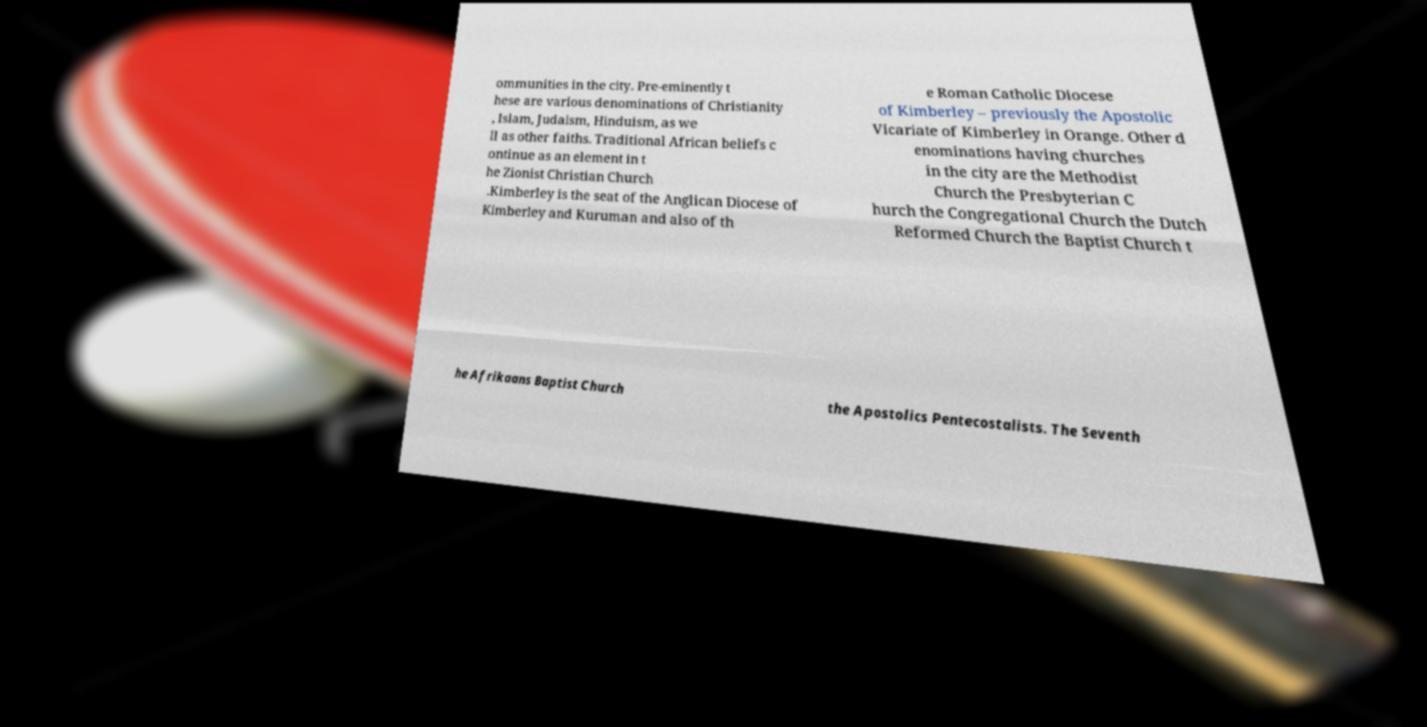Can you read and provide the text displayed in the image?This photo seems to have some interesting text. Can you extract and type it out for me? ommunities in the city. Pre-eminently t hese are various denominations of Christianity , Islam, Judaism, Hinduism, as we ll as other faiths. Traditional African beliefs c ontinue as an element in t he Zionist Christian Church .Kimberley is the seat of the Anglican Diocese of Kimberley and Kuruman and also of th e Roman Catholic Diocese of Kimberley – previously the Apostolic Vicariate of Kimberley in Orange. Other d enominations having churches in the city are the Methodist Church the Presbyterian C hurch the Congregational Church the Dutch Reformed Church the Baptist Church t he Afrikaans Baptist Church the Apostolics Pentecostalists. The Seventh 